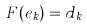Convert formula to latex. <formula><loc_0><loc_0><loc_500><loc_500>F ( e _ { k } ) = d _ { k }</formula> 